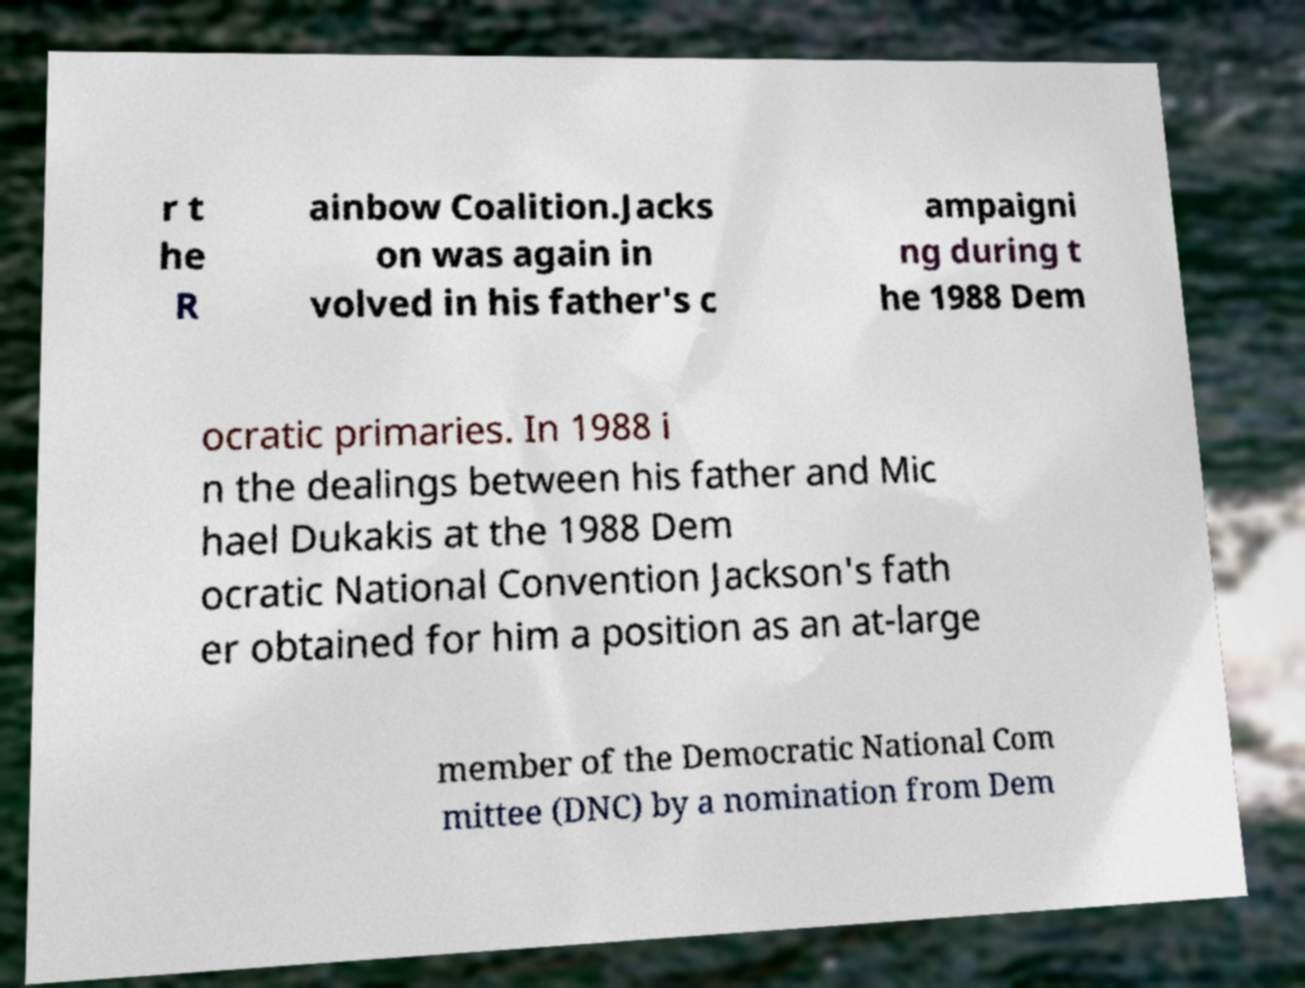Can you accurately transcribe the text from the provided image for me? r t he R ainbow Coalition.Jacks on was again in volved in his father's c ampaigni ng during t he 1988 Dem ocratic primaries. In 1988 i n the dealings between his father and Mic hael Dukakis at the 1988 Dem ocratic National Convention Jackson's fath er obtained for him a position as an at-large member of the Democratic National Com mittee (DNC) by a nomination from Dem 